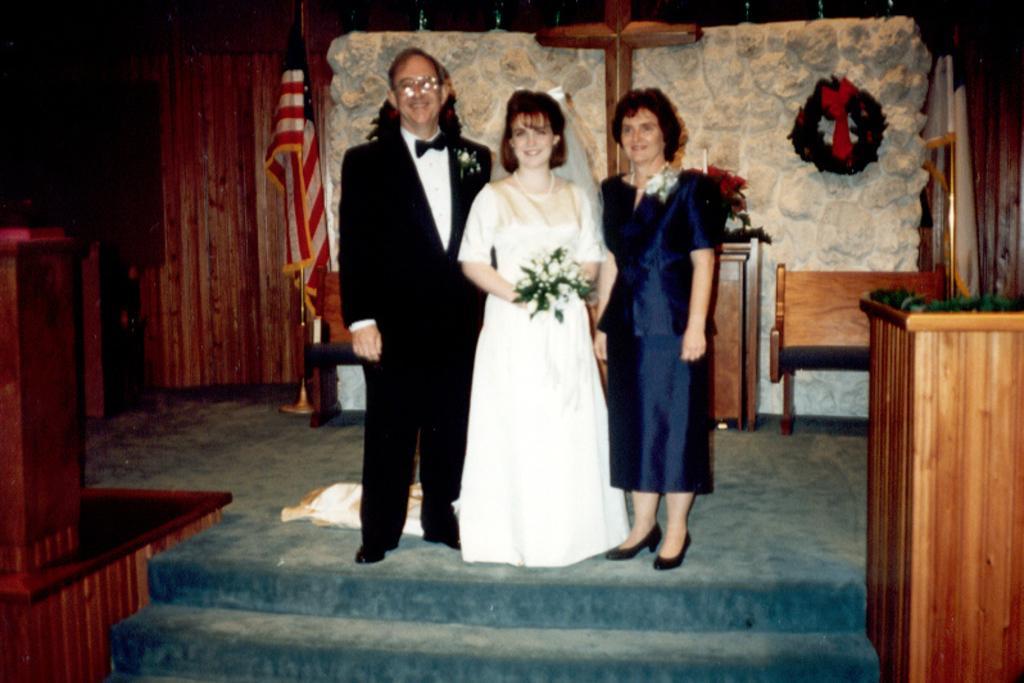How would you summarize this image in a sentence or two? In this picture I can observe three members standing on the floor in the middle of the picture. All of them are smiling. On either sides of the picture I can observe flags. In the background I can observe wall. 